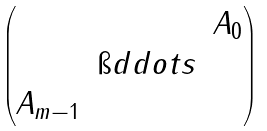Convert formula to latex. <formula><loc_0><loc_0><loc_500><loc_500>\begin{pmatrix} & & A _ { 0 } \\ & \i d d o t s \\ A _ { m - 1 } \end{pmatrix}</formula> 